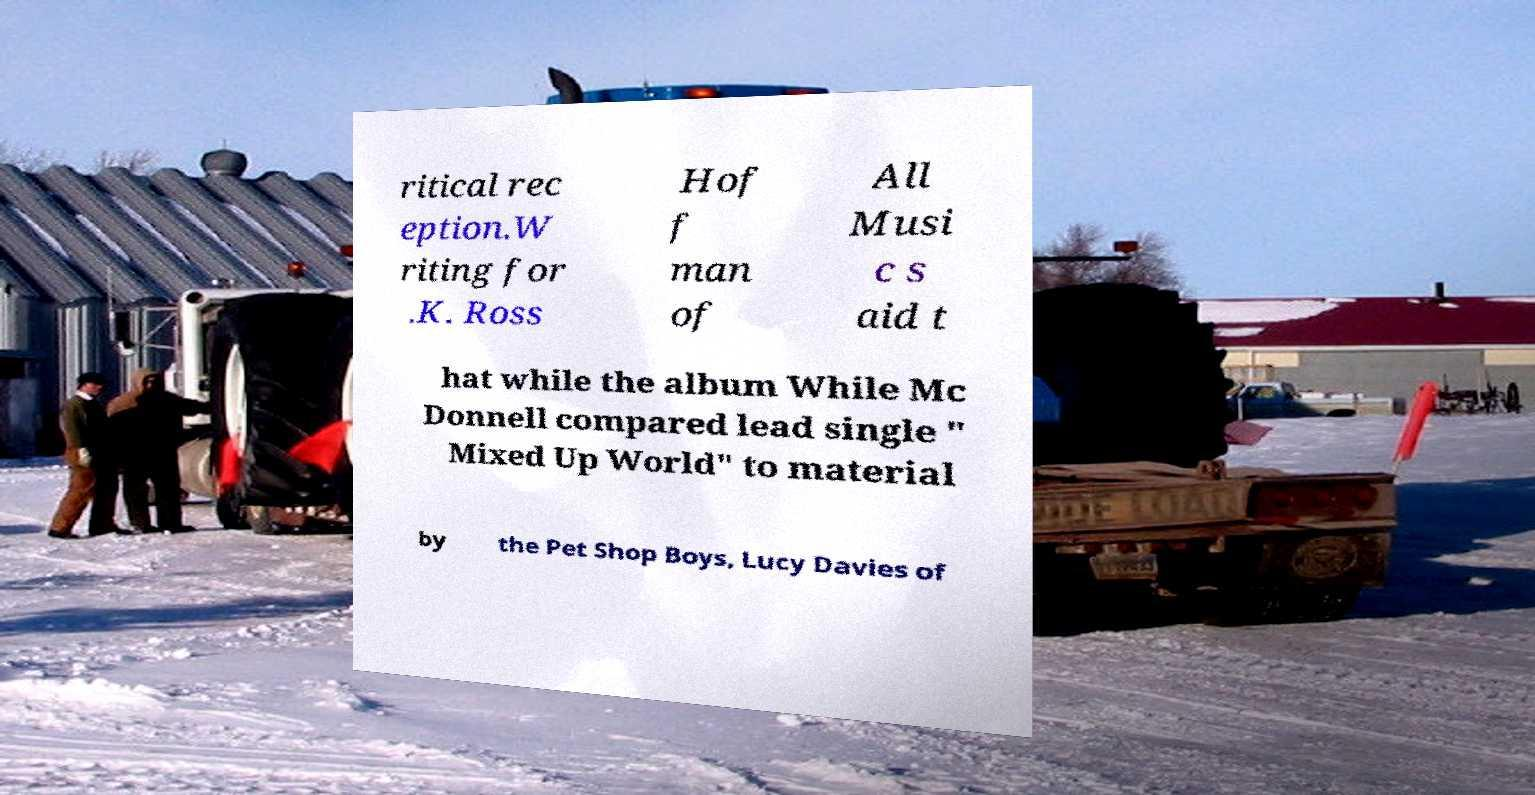Can you accurately transcribe the text from the provided image for me? ritical rec eption.W riting for .K. Ross Hof f man of All Musi c s aid t hat while the album While Mc Donnell compared lead single " Mixed Up World" to material by the Pet Shop Boys, Lucy Davies of 